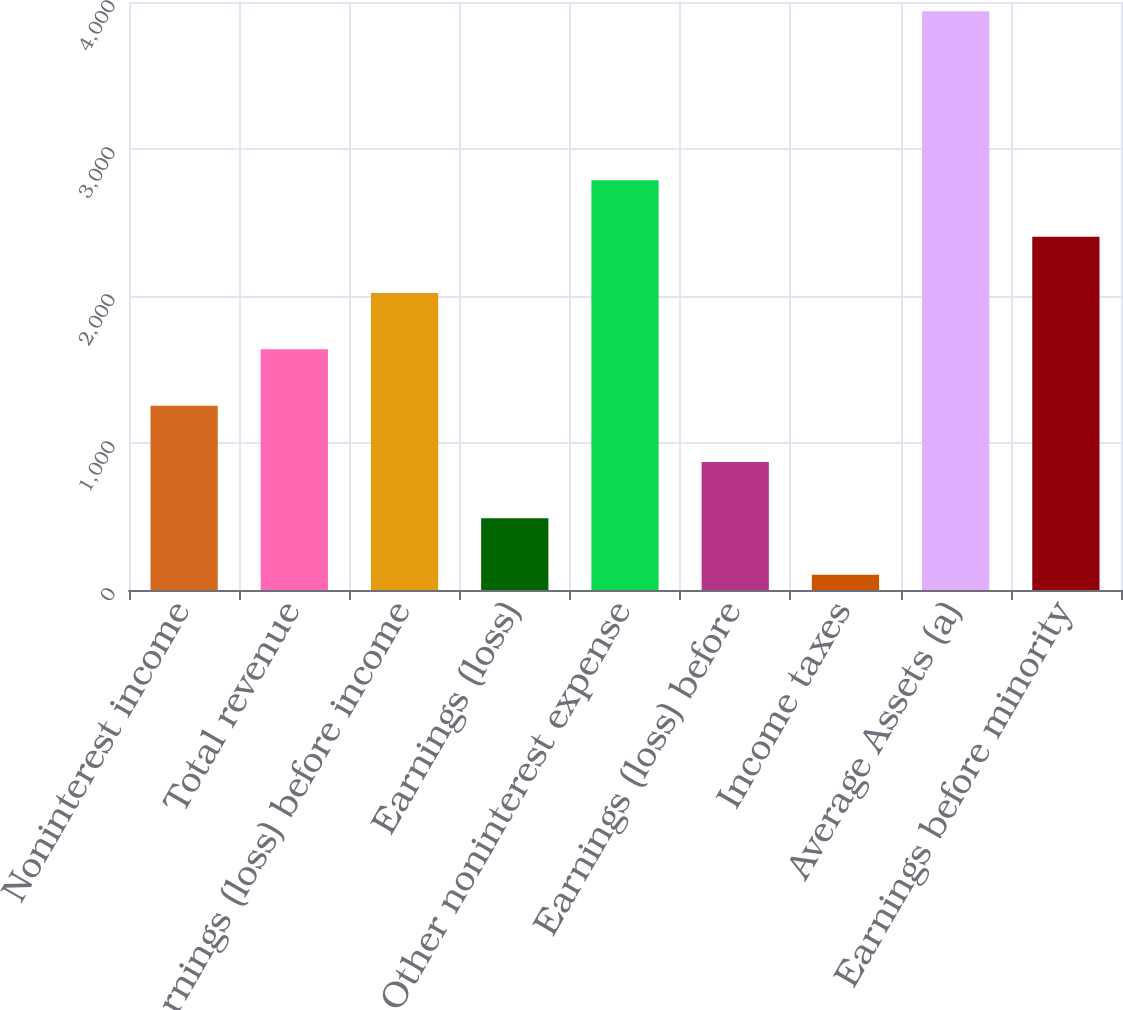Convert chart. <chart><loc_0><loc_0><loc_500><loc_500><bar_chart><fcel>Noninterest income<fcel>Total revenue<fcel>Earnings (loss) before income<fcel>Earnings (loss)<fcel>Other noninterest expense<fcel>Earnings (loss) before<fcel>Income taxes<fcel>Average Assets (a)<fcel>Earnings before minority<nl><fcel>1253.9<fcel>1637.2<fcel>2020.5<fcel>487.3<fcel>2787.1<fcel>870.6<fcel>104<fcel>3937<fcel>2403.8<nl></chart> 